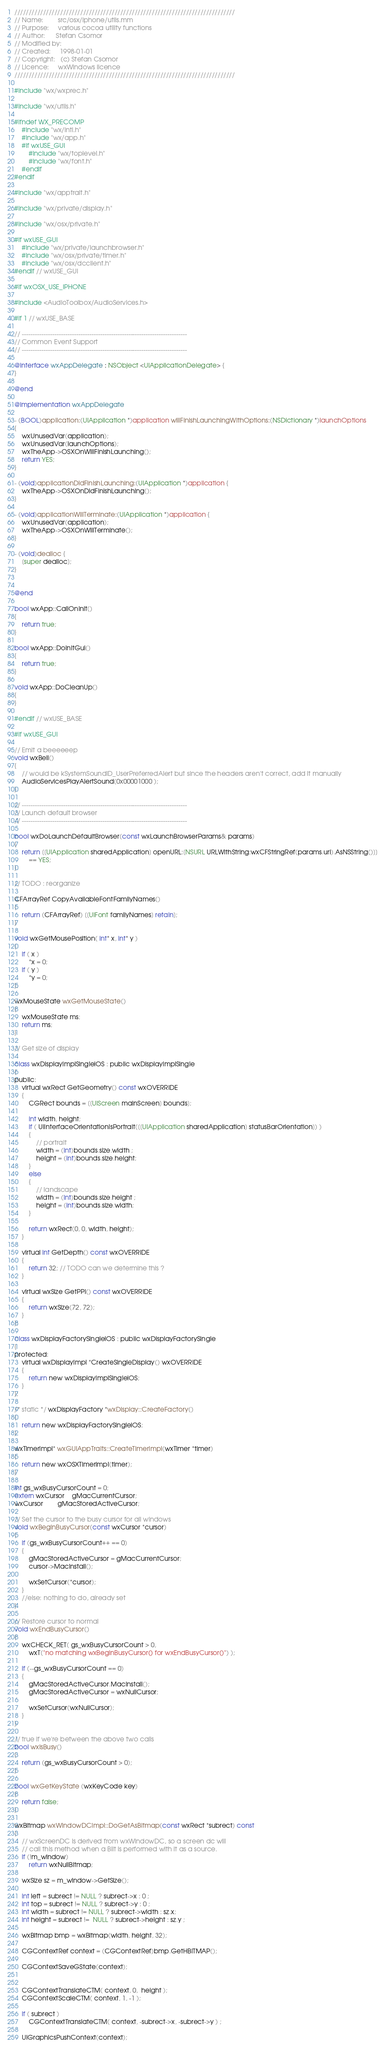<code> <loc_0><loc_0><loc_500><loc_500><_ObjectiveC_>/////////////////////////////////////////////////////////////////////////////
// Name:        src/osx/iphone/utils.mm
// Purpose:     various cocoa utility functions
// Author:      Stefan Csomor
// Modified by:
// Created:     1998-01-01
// Copyright:   (c) Stefan Csomor
// Licence:     wxWindows licence
/////////////////////////////////////////////////////////////////////////////

#include "wx/wxprec.h"

#include "wx/utils.h"

#ifndef WX_PRECOMP
    #include "wx/intl.h"
    #include "wx/app.h"
    #if wxUSE_GUI
        #include "wx/toplevel.h"
        #include "wx/font.h"
    #endif
#endif

#include "wx/apptrait.h"

#include "wx/private/display.h"

#include "wx/osx/private.h"

#if wxUSE_GUI
    #include "wx/private/launchbrowser.h"
    #include "wx/osx/private/timer.h"
    #include "wx/osx/dcclient.h"
#endif // wxUSE_GUI

#if wxOSX_USE_IPHONE

#include <AudioToolbox/AudioServices.h>

#if 1 // wxUSE_BASE

// ----------------------------------------------------------------------------
// Common Event Support
// ----------------------------------------------------------------------------

@interface wxAppDelegate : NSObject <UIApplicationDelegate> {
}

@end

@implementation wxAppDelegate

- (BOOL)application:(UIApplication *)application willFinishLaunchingWithOptions:(NSDictionary *)launchOptions
{
    wxUnusedVar(application);
    wxUnusedVar(launchOptions);
    wxTheApp->OSXOnWillFinishLaunching();
    return YES;
}

- (void)applicationDidFinishLaunching:(UIApplication *)application {
    wxTheApp->OSXOnDidFinishLaunching();
}

- (void)applicationWillTerminate:(UIApplication *)application { 
    wxUnusedVar(application);
    wxTheApp->OSXOnWillTerminate();
}

- (void)dealloc {
    [super dealloc];
}


@end

bool wxApp::CallOnInit()
{
    return true;
}

bool wxApp::DoInitGui()
{
    return true;
}

void wxApp::DoCleanUp()
{
}

#endif // wxUSE_BASE

#if wxUSE_GUI

// Emit a beeeeeep
void wxBell()
{
    // would be kSystemSoundID_UserPreferredAlert but since the headers aren't correct, add it manually
    AudioServicesPlayAlertSound(0x00001000 );
}

// ----------------------------------------------------------------------------
// Launch default browser
// ----------------------------------------------------------------------------

bool wxDoLaunchDefaultBrowser(const wxLaunchBrowserParams& params)
{
    return [[UIApplication sharedApplication] openURL:[NSURL URLWithString:wxCFStringRef(params.url).AsNSString()]]
        == YES;
}

// TODO : reorganize

CFArrayRef CopyAvailableFontFamilyNames()
{
    return (CFArrayRef) [[UIFont familyNames] retain];
}

void wxGetMousePosition( int* x, int* y )
{
    if ( x )
        *x = 0;
    if ( y )
        *y = 0;
};

wxMouseState wxGetMouseState()
{
    wxMouseState ms;
    return ms;
}    

// Get size of display

class wxDisplayImplSingleiOS : public wxDisplayImplSingle
{
public:
    virtual wxRect GetGeometry() const wxOVERRIDE
    {
        CGRect bounds = [[UIScreen mainScreen] bounds];

        int width, height;
        if ( UIInterfaceOrientationIsPortrait([[UIApplication sharedApplication] statusBarOrientation]) )
        {
            // portrait
            width = (int)bounds.size.width ;
            height = (int)bounds.size.height;
        }
        else
        {
            // landscape
            width = (int)bounds.size.height ;
            height = (int)bounds.size.width;
        }

        return wxRect(0, 0, width, height);
    }

    virtual int GetDepth() const wxOVERRIDE
    {
        return 32; // TODO can we determine this ?
    }

    virtual wxSize GetPPI() const wxOVERRIDE
    {
        return wxSize(72, 72);
    }
};

class wxDisplayFactorySingleiOS : public wxDisplayFactorySingle
{
protected:
    virtual wxDisplayImpl *CreateSingleDisplay() wxOVERRIDE
    {
        return new wxDisplayImplSingleiOS;
    }
};

/* static */ wxDisplayFactory *wxDisplay::CreateFactory()
{
    return new wxDisplayFactorySingleiOS;
}

wxTimerImpl* wxGUIAppTraits::CreateTimerImpl(wxTimer *timer)
{
    return new wxOSXTimerImpl(timer);
}

int gs_wxBusyCursorCount = 0;
extern wxCursor    gMacCurrentCursor;
wxCursor        gMacStoredActiveCursor;

// Set the cursor to the busy cursor for all windows
void wxBeginBusyCursor(const wxCursor *cursor)
{
    if (gs_wxBusyCursorCount++ == 0)
    {
        gMacStoredActiveCursor = gMacCurrentCursor;
        cursor->MacInstall();

        wxSetCursor(*cursor);
    }
    //else: nothing to do, already set
}

// Restore cursor to normal
void wxEndBusyCursor()
{
    wxCHECK_RET( gs_wxBusyCursorCount > 0,
        wxT("no matching wxBeginBusyCursor() for wxEndBusyCursor()") );

    if (--gs_wxBusyCursorCount == 0)
    {
        gMacStoredActiveCursor.MacInstall();
        gMacStoredActiveCursor = wxNullCursor;

        wxSetCursor(wxNullCursor);
    }
}

// true if we're between the above two calls
bool wxIsBusy()
{
    return (gs_wxBusyCursorCount > 0);
}

bool wxGetKeyState (wxKeyCode key)
{
    return false;
}

wxBitmap wxWindowDCImpl::DoGetAsBitmap(const wxRect *subrect) const
{
    // wxScreenDC is derived from wxWindowDC, so a screen dc will
    // call this method when a Blit is performed with it as a source.
    if (!m_window)
        return wxNullBitmap;

    wxSize sz = m_window->GetSize();

    int left = subrect != NULL ? subrect->x : 0 ;
    int top = subrect != NULL ? subrect->y : 0 ;
    int width = subrect != NULL ? subrect->width : sz.x;
    int height = subrect !=  NULL ? subrect->height : sz.y ;

    wxBitmap bmp = wxBitmap(width, height, 32);

    CGContextRef context = (CGContextRef)bmp.GetHBITMAP();

    CGContextSaveGState(context);


    CGContextTranslateCTM( context, 0,  height );
    CGContextScaleCTM( context, 1, -1 );

    if ( subrect )
        CGContextTranslateCTM( context, -subrect->x, -subrect->y ) ;

    UIGraphicsPushContext(context);</code> 